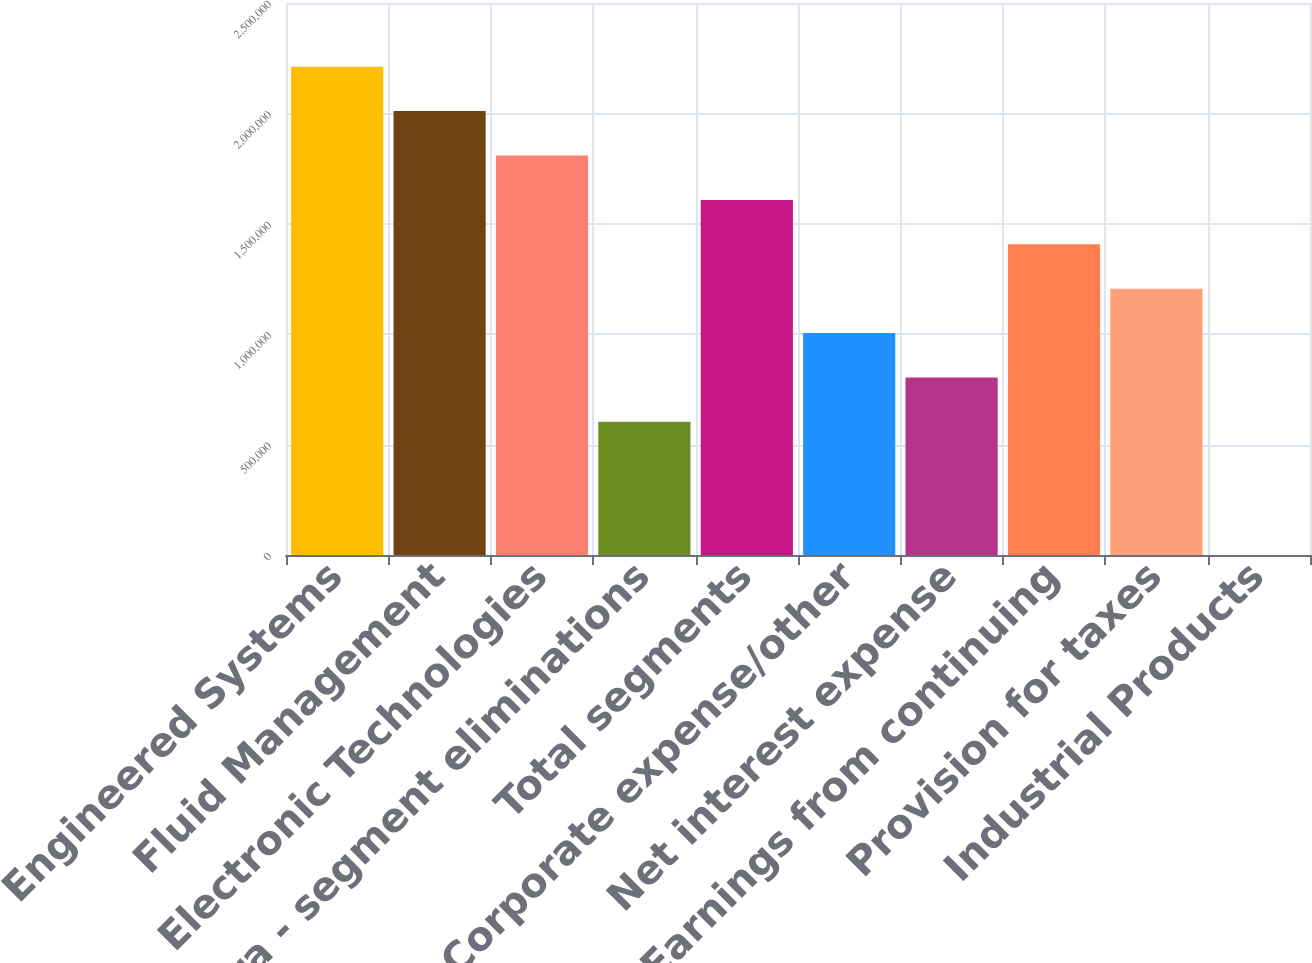Convert chart. <chart><loc_0><loc_0><loc_500><loc_500><bar_chart><fcel>Engineered Systems<fcel>Fluid Management<fcel>Electronic Technologies<fcel>Intra - segment eliminations<fcel>Total segments<fcel>Corporate expense/other<fcel>Net interest expense<fcel>Earnings from continuing<fcel>Provision for taxes<fcel>Industrial Products<nl><fcel>2.21138e+06<fcel>2.01035e+06<fcel>1.80932e+06<fcel>603114<fcel>1.60828e+06<fcel>1.00518e+06<fcel>804147<fcel>1.40725e+06<fcel>1.20621e+06<fcel>12.2<nl></chart> 